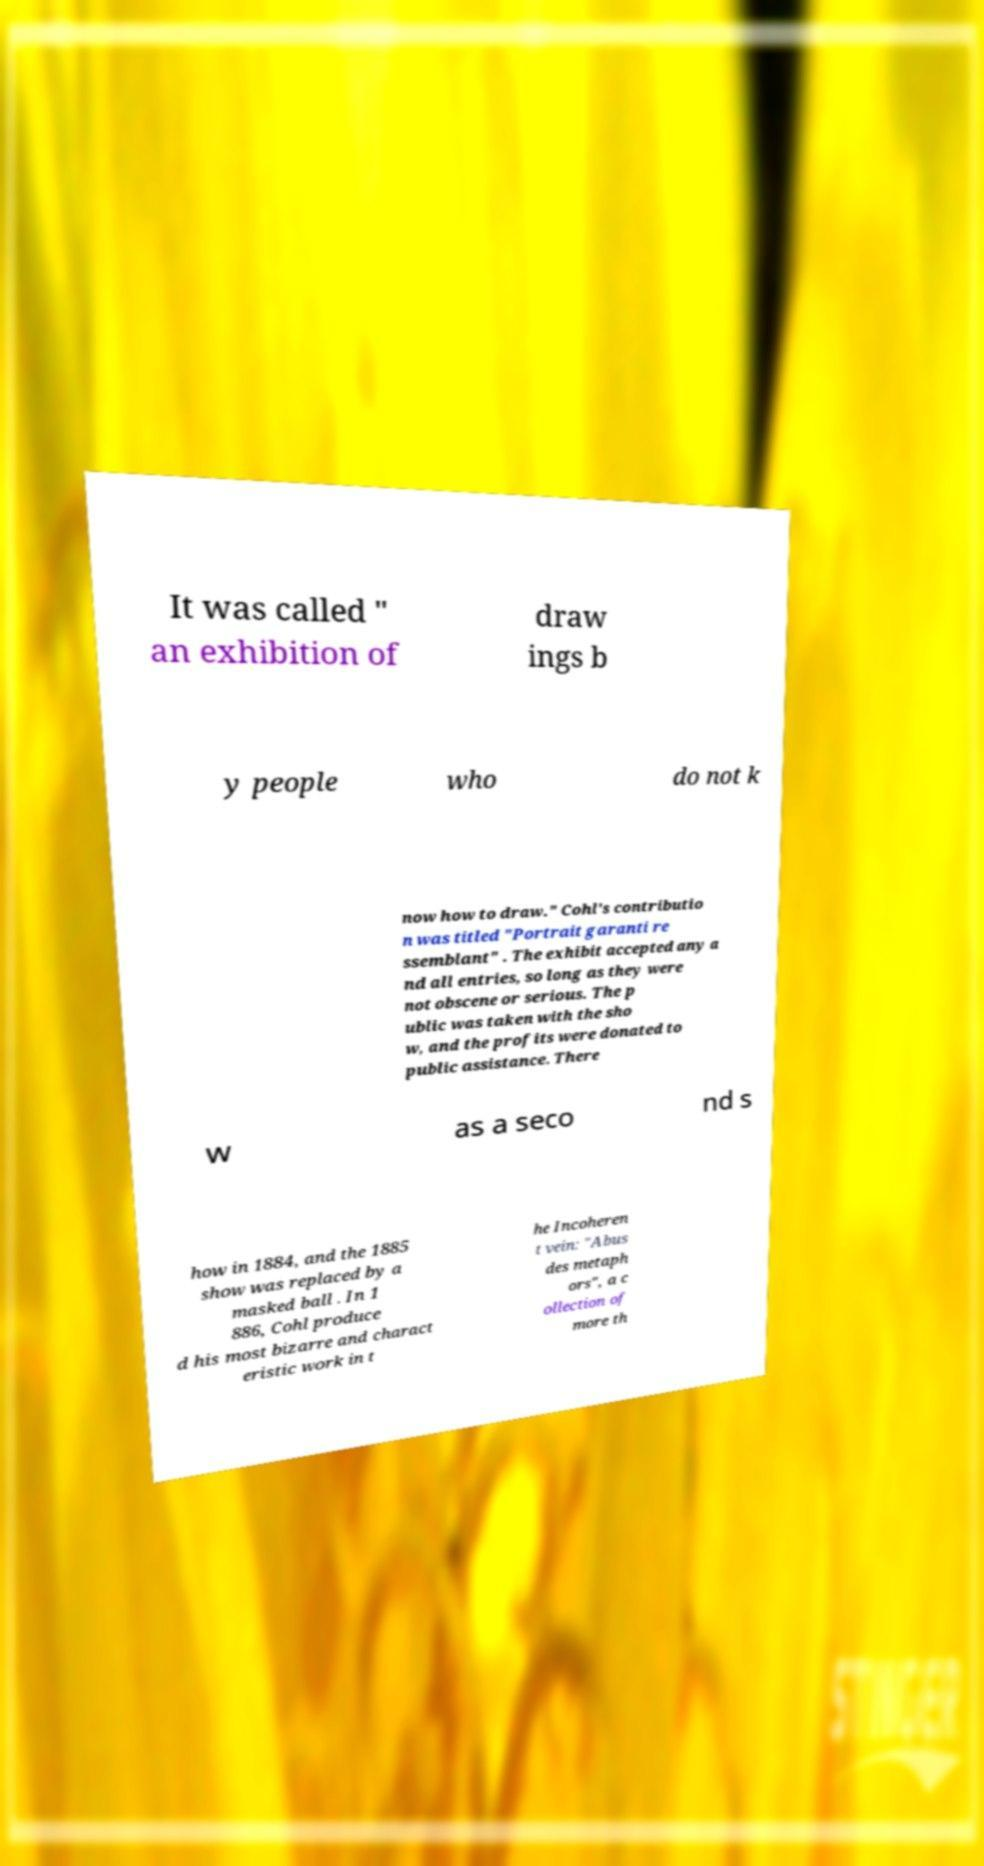I need the written content from this picture converted into text. Can you do that? It was called " an exhibition of draw ings b y people who do not k now how to draw." Cohl's contributio n was titled "Portrait garanti re ssemblant" . The exhibit accepted any a nd all entries, so long as they were not obscene or serious. The p ublic was taken with the sho w, and the profits were donated to public assistance. There w as a seco nd s how in 1884, and the 1885 show was replaced by a masked ball . In 1 886, Cohl produce d his most bizarre and charact eristic work in t he Incoheren t vein: "Abus des metaph ors", a c ollection of more th 